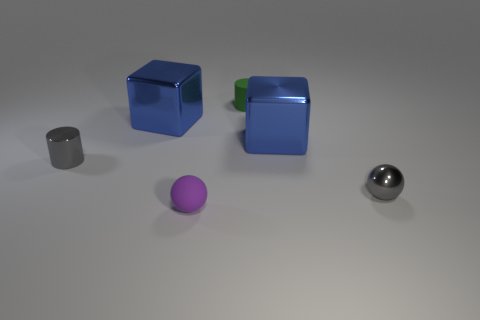What is the shape of the small object that is both on the right side of the tiny purple sphere and to the left of the tiny gray metal sphere?
Offer a very short reply. Cylinder. There is a small gray shiny object to the left of the purple rubber thing; what shape is it?
Offer a terse response. Cylinder. How many small gray objects are behind the gray ball and in front of the gray metallic cylinder?
Your answer should be compact. 0. Do the purple ball and the blue shiny cube on the left side of the green thing have the same size?
Your answer should be very brief. No. What size is the matte ball to the left of the tiny gray ball that is in front of the cube left of the small rubber sphere?
Provide a short and direct response. Small. What is the size of the green object to the left of the gray ball?
Your answer should be compact. Small. What is the shape of the other small thing that is the same material as the small green thing?
Your answer should be compact. Sphere. Are the cylinder that is to the right of the purple matte thing and the gray cylinder made of the same material?
Offer a very short reply. No. What number of other things are there of the same material as the green cylinder
Your answer should be very brief. 1. How many things are either tiny shiny things behind the small gray shiny sphere or blue shiny cubes on the right side of the small green rubber cylinder?
Keep it short and to the point. 2. 